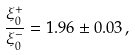Convert formula to latex. <formula><loc_0><loc_0><loc_500><loc_500>\frac { \xi _ { 0 } ^ { + } } { \xi _ { 0 } ^ { - } } = 1 . 9 6 \pm 0 . 0 3 \, ,</formula> 